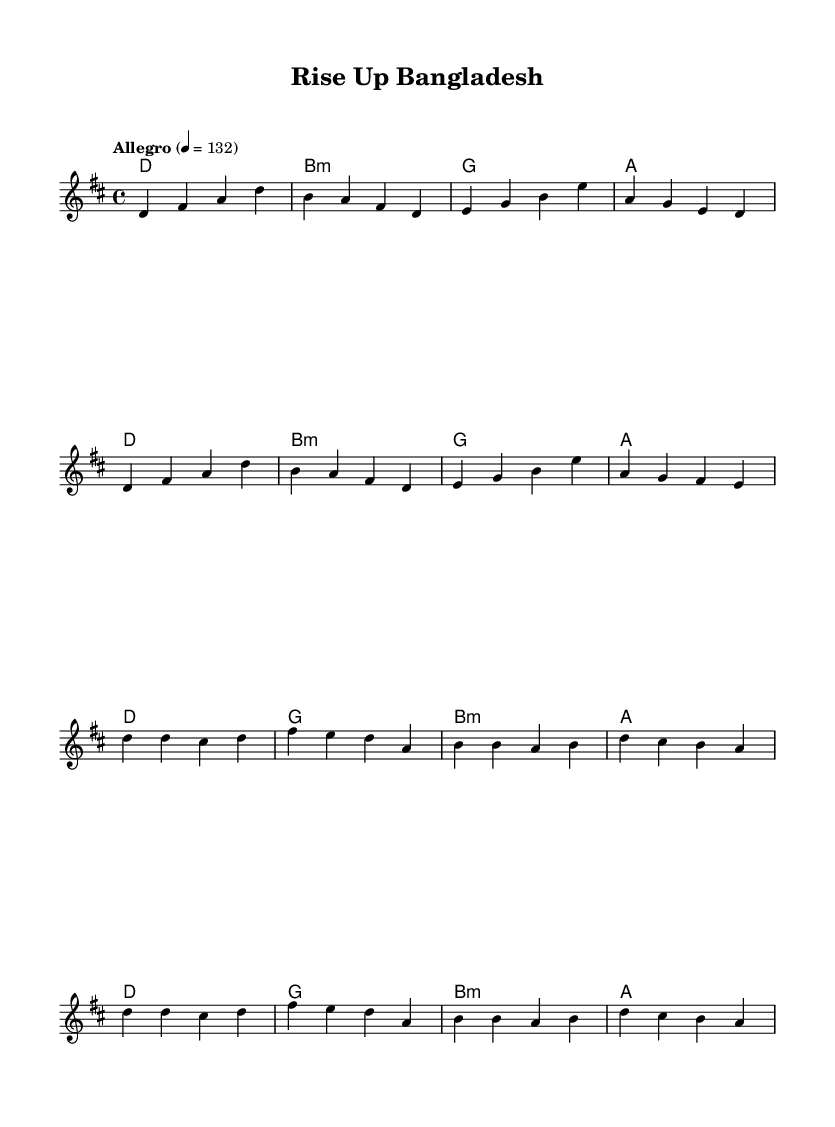What is the key signature of this music? The key signature is D major, indicated by two sharps (F# and C#), which can be inferred from the global settings in the code, where it specifies "\key d \major".
Answer: D major What is the time signature of this music? The time signature is 4/4, as stated in the global settings of the code with "\time 4/4". This means there are four beats per measure.
Answer: 4/4 What is the tempo marking for this piece? The tempo marking is Allegro, set at 132 beats per minute, which is specified in the global settings with "\tempo 'Allegro' 4 = 132".
Answer: Allegro How many measures are in the verse section? The verse consists of 8 measures, which can be counted from the melody section where the verse pattern is laid out without any markings for breaks.
Answer: 8 What is the last chord in the chorus? The last chord in the chorus is A major, which is the final chord specified in the harmony section during the chorus part following the melodic structure.
Answer: A What note begins the chorus? The chorus starts with the note D, as seen in the beginning of the chorus melody where the first note is indicated as d'.
Answer: D What is the chord progression of the verse? The chord progression of the verse is D - B minor - G - A, which corresponds with the harmonies defined in the verse section, showing the order of chords played.
Answer: D - B minor - G - A 